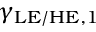Convert formula to latex. <formula><loc_0><loc_0><loc_500><loc_500>\gamma _ { L E / H E , 1 }</formula> 